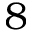<formula> <loc_0><loc_0><loc_500><loc_500>8</formula> 